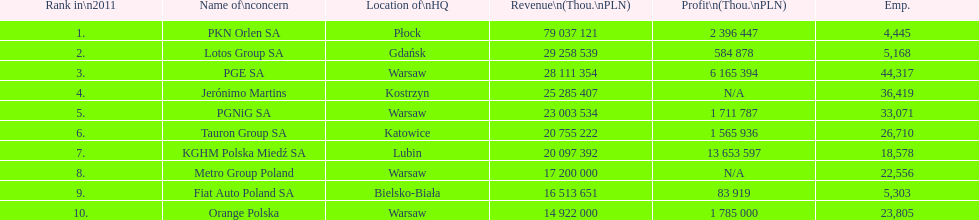What is the count of workers employed by pgnig sa? 33,071. 